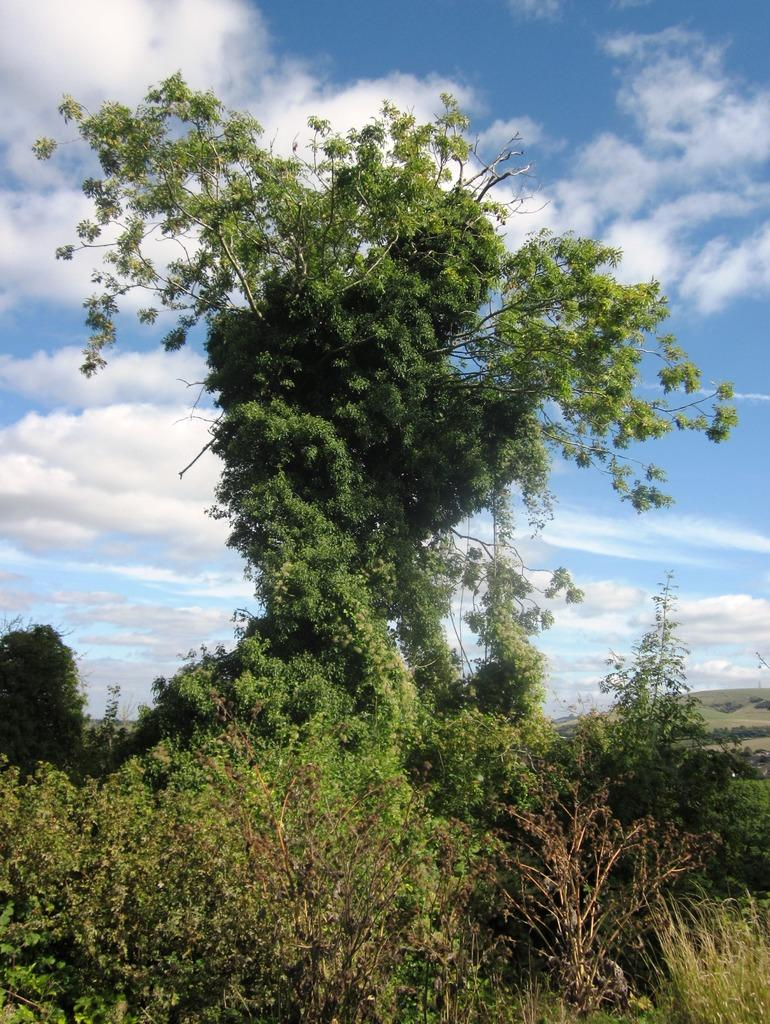What is the main subject in the middle of the image? There is a tree in the middle of the image. What can be seen at the top of the image? The sky is visible at the top of the image. How would you describe the weather based on the appearance of the sky? The sky appears to be sunny, suggesting a clear and bright day. Can you see a dog or a ghost in the image? No, there is no dog or ghost present in the image. The image only features a tree and the sky. 